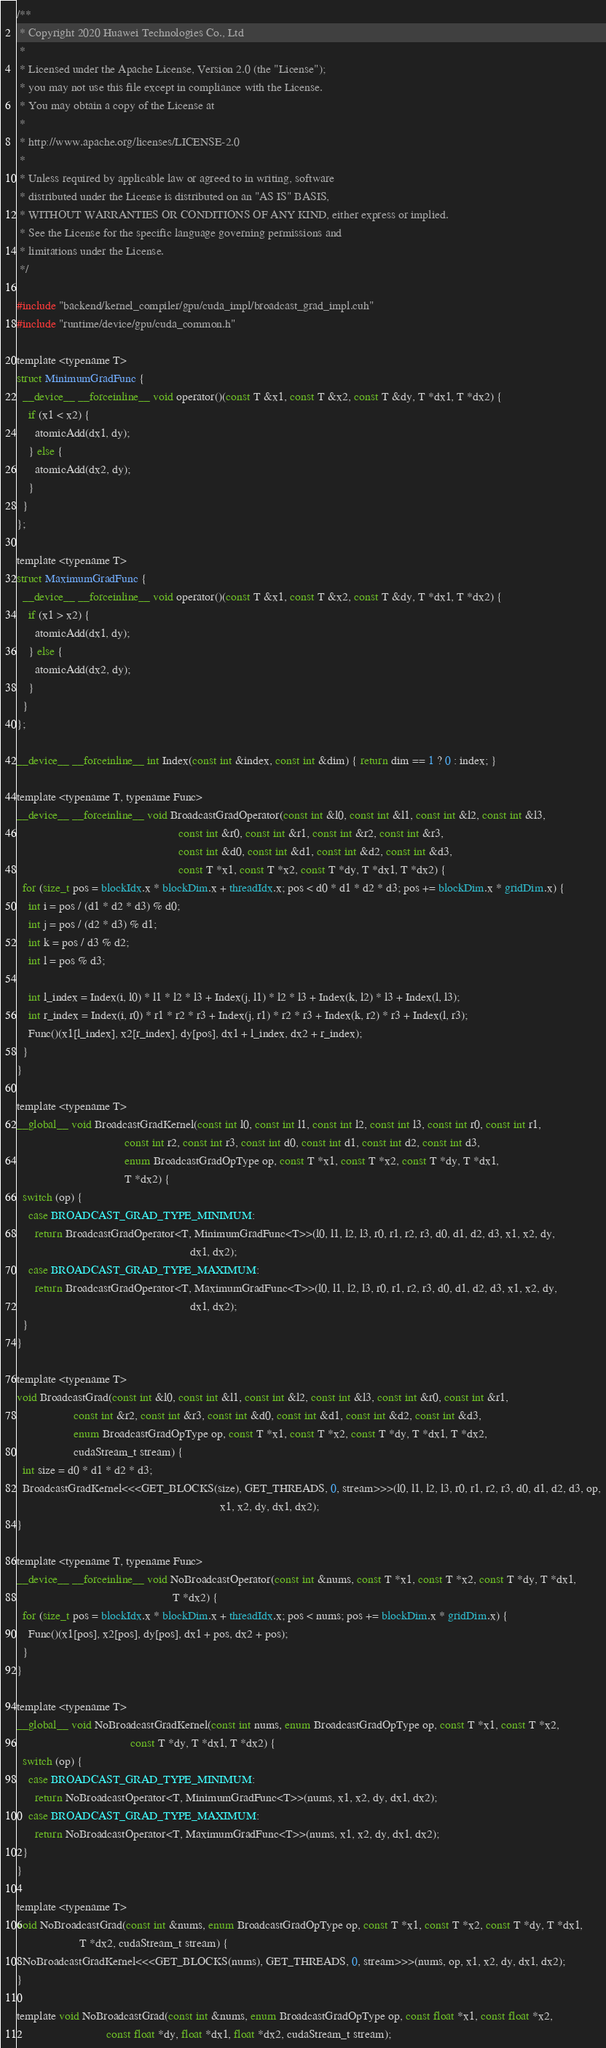<code> <loc_0><loc_0><loc_500><loc_500><_Cuda_>/**
 * Copyright 2020 Huawei Technologies Co., Ltd
 *
 * Licensed under the Apache License, Version 2.0 (the "License");
 * you may not use this file except in compliance with the License.
 * You may obtain a copy of the License at
 *
 * http://www.apache.org/licenses/LICENSE-2.0
 *
 * Unless required by applicable law or agreed to in writing, software
 * distributed under the License is distributed on an "AS IS" BASIS,
 * WITHOUT WARRANTIES OR CONDITIONS OF ANY KIND, either express or implied.
 * See the License for the specific language governing permissions and
 * limitations under the License.
 */

#include "backend/kernel_compiler/gpu/cuda_impl/broadcast_grad_impl.cuh"
#include "runtime/device/gpu/cuda_common.h"

template <typename T>
struct MinimumGradFunc {
  __device__ __forceinline__ void operator()(const T &x1, const T &x2, const T &dy, T *dx1, T *dx2) {
    if (x1 < x2) {
      atomicAdd(dx1, dy);
    } else {
      atomicAdd(dx2, dy);
    }
  }
};

template <typename T>
struct MaximumGradFunc {
  __device__ __forceinline__ void operator()(const T &x1, const T &x2, const T &dy, T *dx1, T *dx2) {
    if (x1 > x2) {
      atomicAdd(dx1, dy);
    } else {
      atomicAdd(dx2, dy);
    }
  }
};

__device__ __forceinline__ int Index(const int &index, const int &dim) { return dim == 1 ? 0 : index; }

template <typename T, typename Func>
__device__ __forceinline__ void BroadcastGradOperator(const int &l0, const int &l1, const int &l2, const int &l3,
                                                      const int &r0, const int &r1, const int &r2, const int &r3,
                                                      const int &d0, const int &d1, const int &d2, const int &d3,
                                                      const T *x1, const T *x2, const T *dy, T *dx1, T *dx2) {
  for (size_t pos = blockIdx.x * blockDim.x + threadIdx.x; pos < d0 * d1 * d2 * d3; pos += blockDim.x * gridDim.x) {
    int i = pos / (d1 * d2 * d3) % d0;
    int j = pos / (d2 * d3) % d1;
    int k = pos / d3 % d2;
    int l = pos % d3;

    int l_index = Index(i, l0) * l1 * l2 * l3 + Index(j, l1) * l2 * l3 + Index(k, l2) * l3 + Index(l, l3);
    int r_index = Index(i, r0) * r1 * r2 * r3 + Index(j, r1) * r2 * r3 + Index(k, r2) * r3 + Index(l, r3);
    Func()(x1[l_index], x2[r_index], dy[pos], dx1 + l_index, dx2 + r_index);
  }
}

template <typename T>
__global__ void BroadcastGradKernel(const int l0, const int l1, const int l2, const int l3, const int r0, const int r1,
                                    const int r2, const int r3, const int d0, const int d1, const int d2, const int d3,
                                    enum BroadcastGradOpType op, const T *x1, const T *x2, const T *dy, T *dx1,
                                    T *dx2) {
  switch (op) {
    case BROADCAST_GRAD_TYPE_MINIMUM:
      return BroadcastGradOperator<T, MinimumGradFunc<T>>(l0, l1, l2, l3, r0, r1, r2, r3, d0, d1, d2, d3, x1, x2, dy,
                                                          dx1, dx2);
    case BROADCAST_GRAD_TYPE_MAXIMUM:
      return BroadcastGradOperator<T, MaximumGradFunc<T>>(l0, l1, l2, l3, r0, r1, r2, r3, d0, d1, d2, d3, x1, x2, dy,
                                                          dx1, dx2);
  }
}

template <typename T>
void BroadcastGrad(const int &l0, const int &l1, const int &l2, const int &l3, const int &r0, const int &r1,
                   const int &r2, const int &r3, const int &d0, const int &d1, const int &d2, const int &d3,
                   enum BroadcastGradOpType op, const T *x1, const T *x2, const T *dy, T *dx1, T *dx2,
                   cudaStream_t stream) {
  int size = d0 * d1 * d2 * d3;
  BroadcastGradKernel<<<GET_BLOCKS(size), GET_THREADS, 0, stream>>>(l0, l1, l2, l3, r0, r1, r2, r3, d0, d1, d2, d3, op,
                                                                    x1, x2, dy, dx1, dx2);
}

template <typename T, typename Func>
__device__ __forceinline__ void NoBroadcastOperator(const int &nums, const T *x1, const T *x2, const T *dy, T *dx1,
                                                    T *dx2) {
  for (size_t pos = blockIdx.x * blockDim.x + threadIdx.x; pos < nums; pos += blockDim.x * gridDim.x) {
    Func()(x1[pos], x2[pos], dy[pos], dx1 + pos, dx2 + pos);
  }
}

template <typename T>
__global__ void NoBroadcastGradKernel(const int nums, enum BroadcastGradOpType op, const T *x1, const T *x2,
                                      const T *dy, T *dx1, T *dx2) {
  switch (op) {
    case BROADCAST_GRAD_TYPE_MINIMUM:
      return NoBroadcastOperator<T, MinimumGradFunc<T>>(nums, x1, x2, dy, dx1, dx2);
    case BROADCAST_GRAD_TYPE_MAXIMUM:
      return NoBroadcastOperator<T, MaximumGradFunc<T>>(nums, x1, x2, dy, dx1, dx2);
  }
}

template <typename T>
void NoBroadcastGrad(const int &nums, enum BroadcastGradOpType op, const T *x1, const T *x2, const T *dy, T *dx1,
                     T *dx2, cudaStream_t stream) {
  NoBroadcastGradKernel<<<GET_BLOCKS(nums), GET_THREADS, 0, stream>>>(nums, op, x1, x2, dy, dx1, dx2);
}

template void NoBroadcastGrad(const int &nums, enum BroadcastGradOpType op, const float *x1, const float *x2,
                              const float *dy, float *dx1, float *dx2, cudaStream_t stream);</code> 